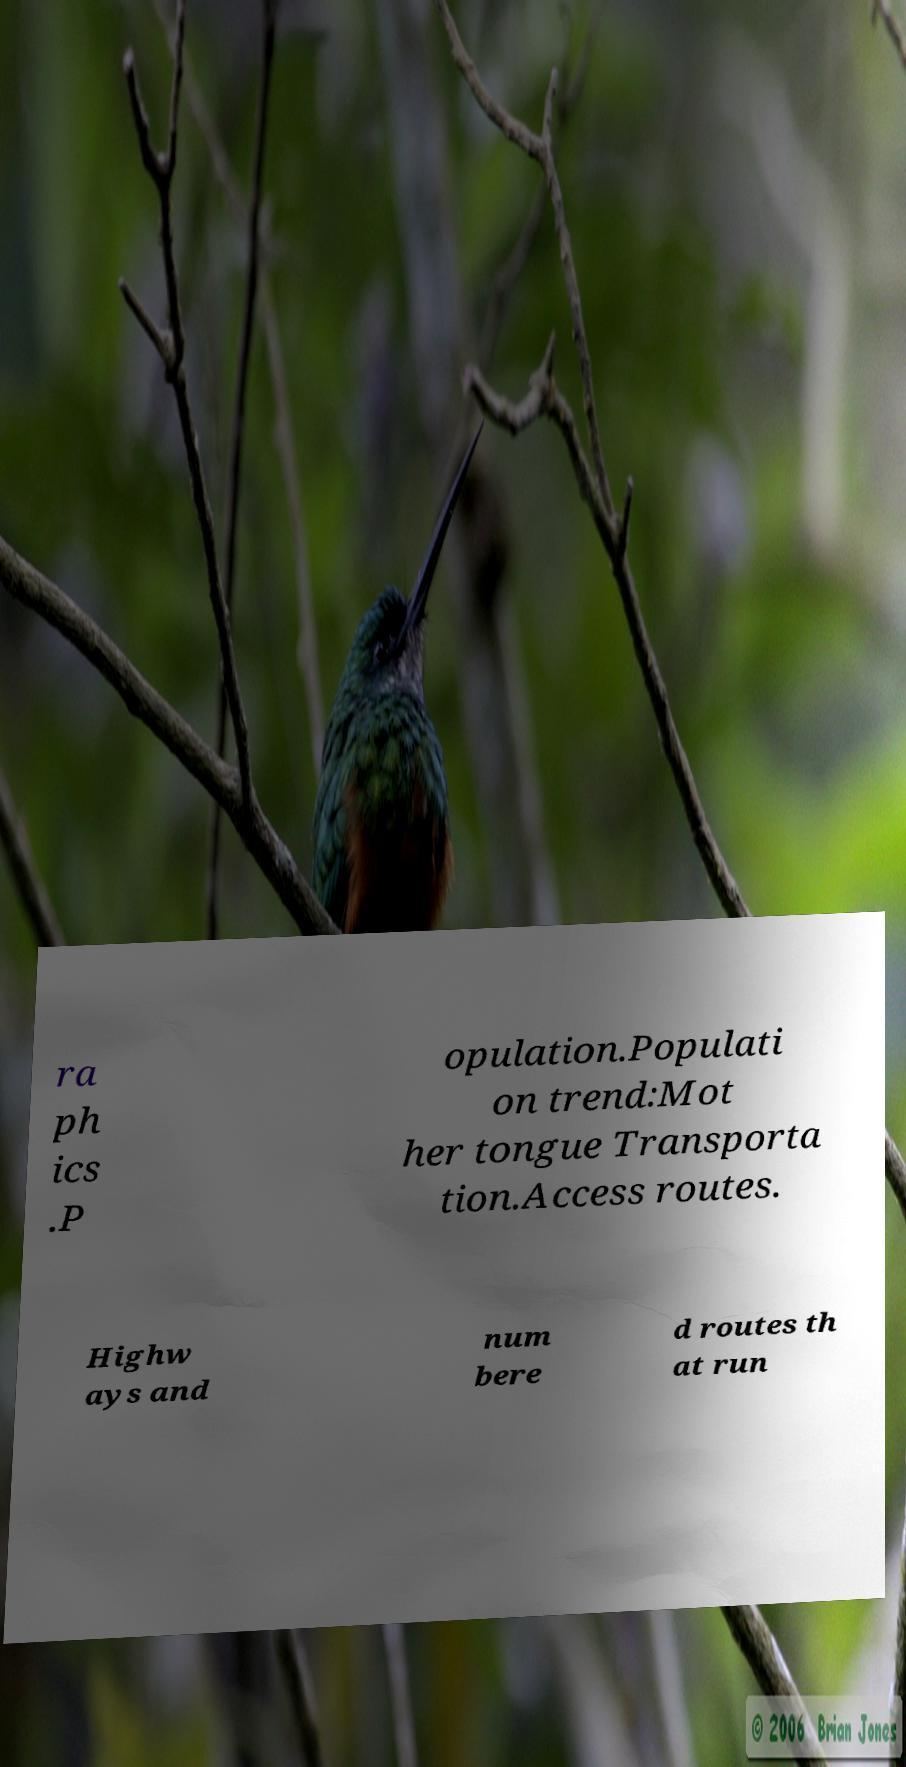There's text embedded in this image that I need extracted. Can you transcribe it verbatim? ra ph ics .P opulation.Populati on trend:Mot her tongue Transporta tion.Access routes. Highw ays and num bere d routes th at run 